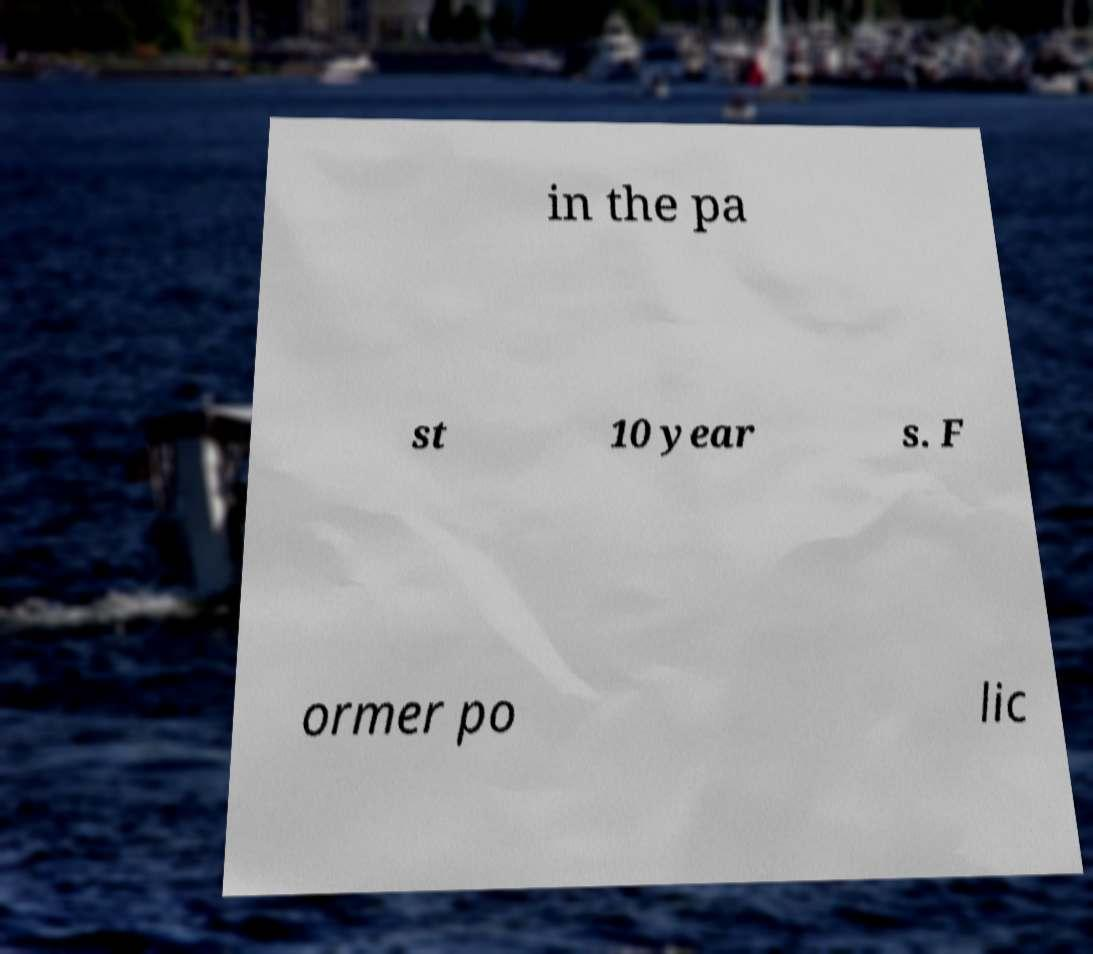Could you extract and type out the text from this image? in the pa st 10 year s. F ormer po lic 